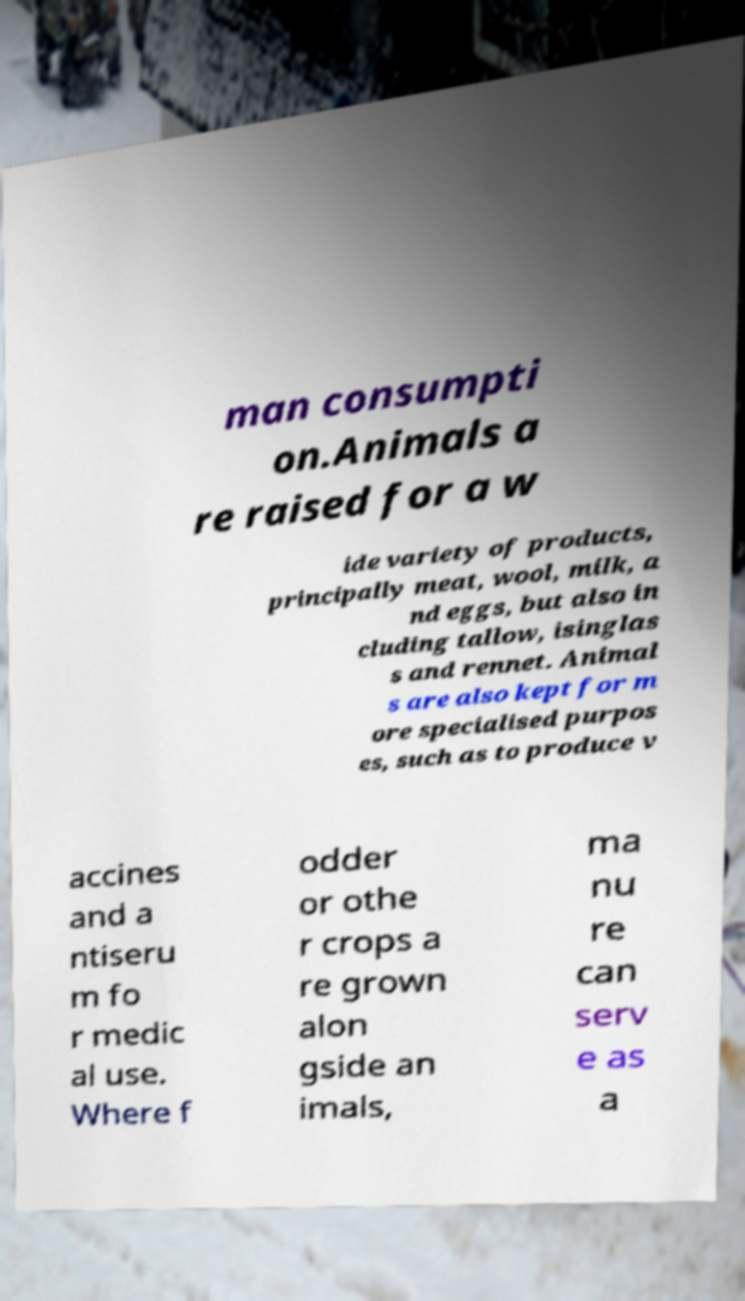There's text embedded in this image that I need extracted. Can you transcribe it verbatim? man consumpti on.Animals a re raised for a w ide variety of products, principally meat, wool, milk, a nd eggs, but also in cluding tallow, isinglas s and rennet. Animal s are also kept for m ore specialised purpos es, such as to produce v accines and a ntiseru m fo r medic al use. Where f odder or othe r crops a re grown alon gside an imals, ma nu re can serv e as a 